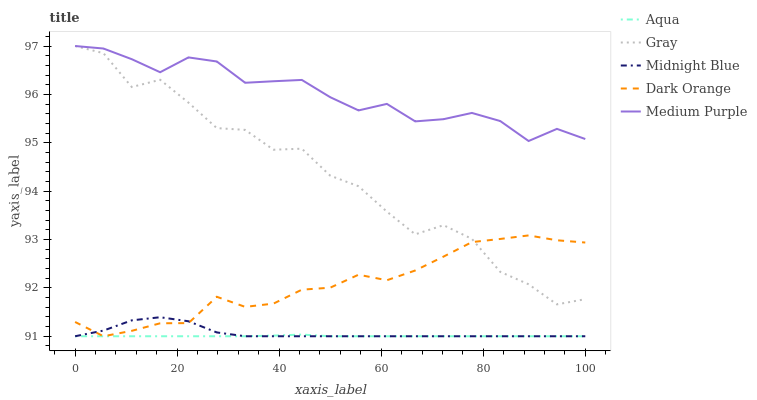Does Aqua have the minimum area under the curve?
Answer yes or no. Yes. Does Medium Purple have the maximum area under the curve?
Answer yes or no. Yes. Does Gray have the minimum area under the curve?
Answer yes or no. No. Does Gray have the maximum area under the curve?
Answer yes or no. No. Is Aqua the smoothest?
Answer yes or no. Yes. Is Gray the roughest?
Answer yes or no. Yes. Is Gray the smoothest?
Answer yes or no. No. Is Aqua the roughest?
Answer yes or no. No. Does Aqua have the lowest value?
Answer yes or no. Yes. Does Gray have the lowest value?
Answer yes or no. No. Does Gray have the highest value?
Answer yes or no. Yes. Does Aqua have the highest value?
Answer yes or no. No. Is Dark Orange less than Medium Purple?
Answer yes or no. Yes. Is Medium Purple greater than Aqua?
Answer yes or no. Yes. Does Dark Orange intersect Aqua?
Answer yes or no. Yes. Is Dark Orange less than Aqua?
Answer yes or no. No. Is Dark Orange greater than Aqua?
Answer yes or no. No. Does Dark Orange intersect Medium Purple?
Answer yes or no. No. 